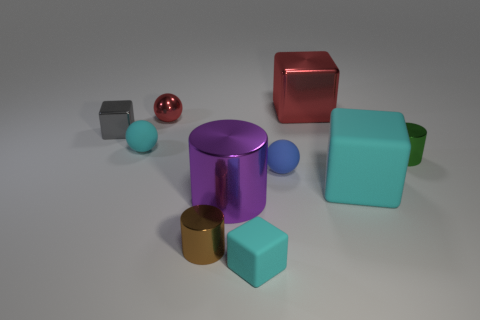Subtract all tiny shiny cylinders. How many cylinders are left? 1 Subtract all cylinders. How many objects are left? 7 Subtract 2 blocks. How many blocks are left? 2 Subtract all blue balls. How many balls are left? 2 Subtract all purple cylinders. How many purple balls are left? 0 Subtract all big red shiny blocks. Subtract all large red blocks. How many objects are left? 8 Add 1 metal objects. How many metal objects are left? 7 Add 7 shiny blocks. How many shiny blocks exist? 9 Subtract 1 red blocks. How many objects are left? 9 Subtract all purple blocks. Subtract all gray cylinders. How many blocks are left? 4 